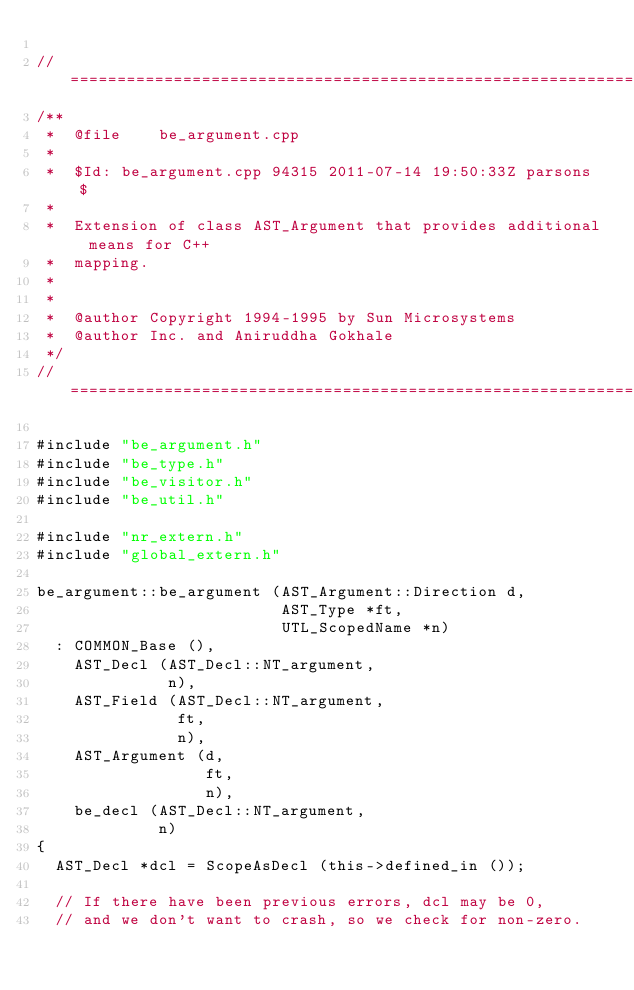<code> <loc_0><loc_0><loc_500><loc_500><_C++_>
//=============================================================================
/**
 *  @file    be_argument.cpp
 *
 *  $Id: be_argument.cpp 94315 2011-07-14 19:50:33Z parsons $
 *
 *  Extension of class AST_Argument that provides additional means for C++
 *  mapping.
 *
 *
 *  @author Copyright 1994-1995 by Sun Microsystems
 *  @author Inc. and Aniruddha Gokhale
 */
//=============================================================================

#include "be_argument.h"
#include "be_type.h"
#include "be_visitor.h"
#include "be_util.h"

#include "nr_extern.h"
#include "global_extern.h"

be_argument::be_argument (AST_Argument::Direction d,
                          AST_Type *ft,
                          UTL_ScopedName *n)
  : COMMON_Base (),
    AST_Decl (AST_Decl::NT_argument,
              n),
    AST_Field (AST_Decl::NT_argument,
               ft,
               n),
    AST_Argument (d,
                  ft,
                  n),
    be_decl (AST_Decl::NT_argument,
             n)
{
  AST_Decl *dcl = ScopeAsDecl (this->defined_in ());

  // If there have been previous errors, dcl may be 0,
  // and we don't want to crash, so we check for non-zero.</code> 